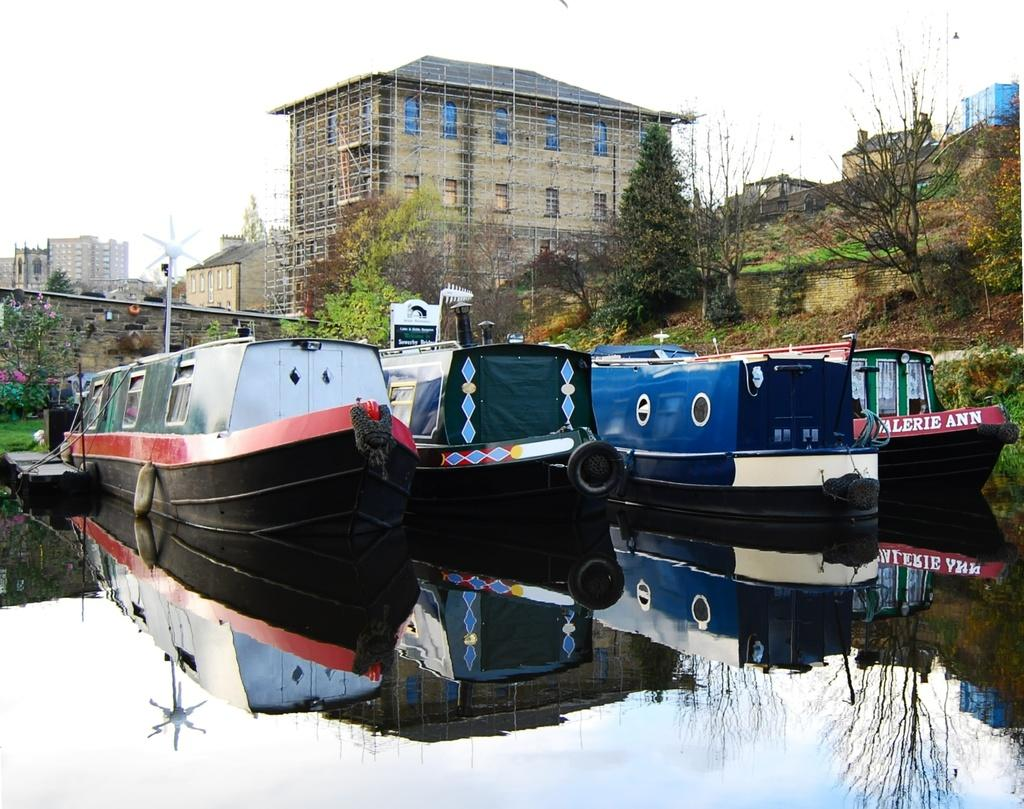What is the primary element in the image? There is water in the image. What is floating on the water? There are boats on the water. What can be seen in the background of the image? There are buildings, trees, and the sky visible in the background of the image. Where is the cannon located in the image? There is no cannon present in the image. What historical event is depicted in the image? The image does not depict any specific historical event. 